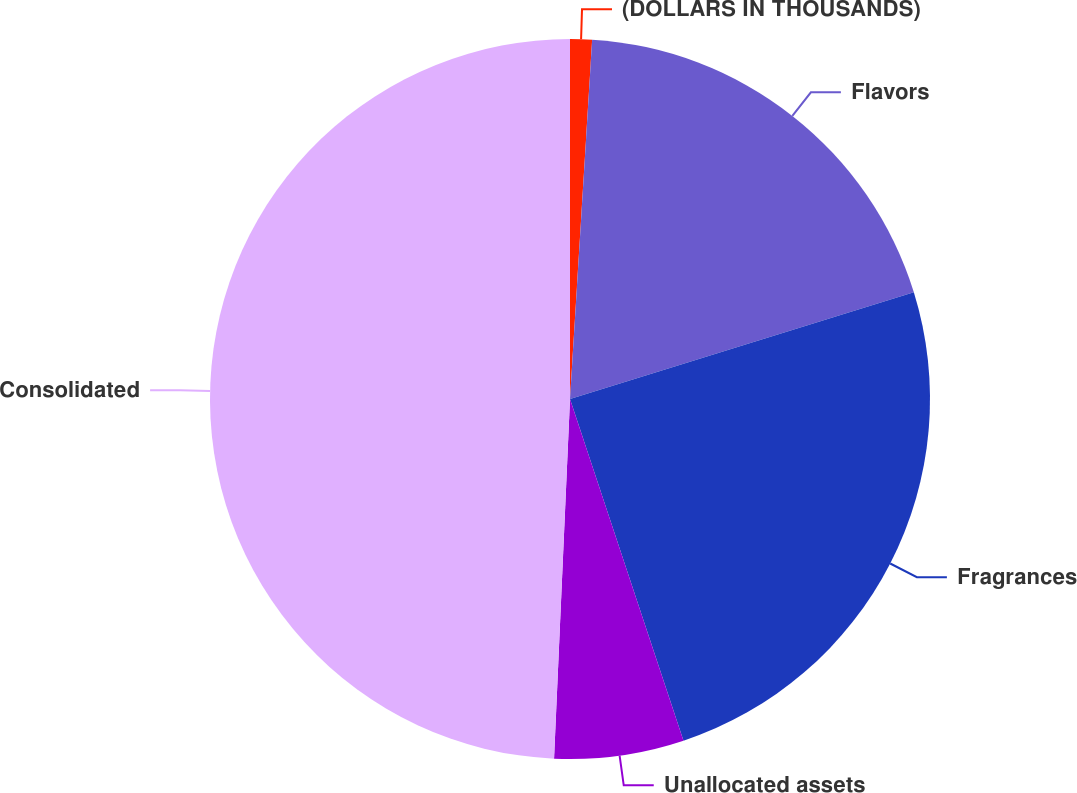Convert chart to OTSL. <chart><loc_0><loc_0><loc_500><loc_500><pie_chart><fcel>(DOLLARS IN THOUSANDS)<fcel>Flavors<fcel>Fragrances<fcel>Unallocated assets<fcel>Consolidated<nl><fcel>0.98%<fcel>19.23%<fcel>24.68%<fcel>5.81%<fcel>49.29%<nl></chart> 